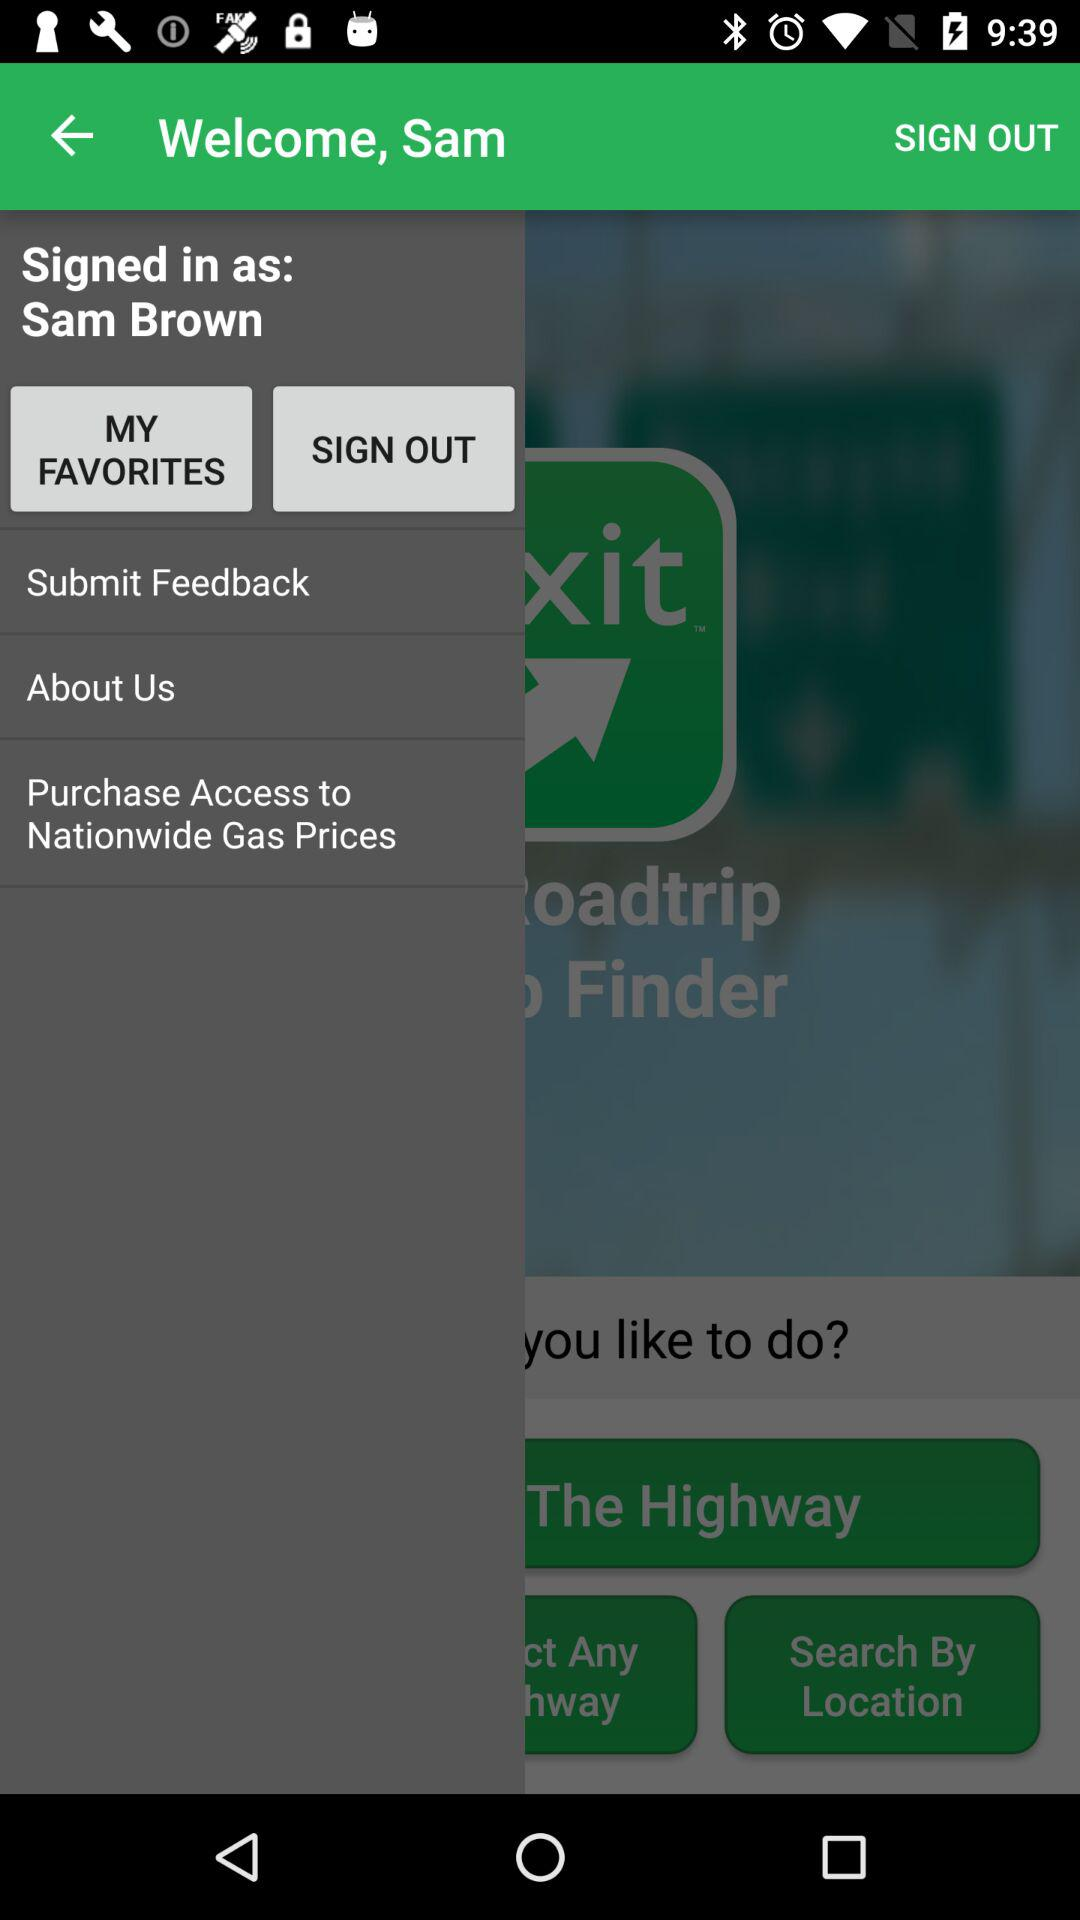What is the user name? The user name is Sam. 